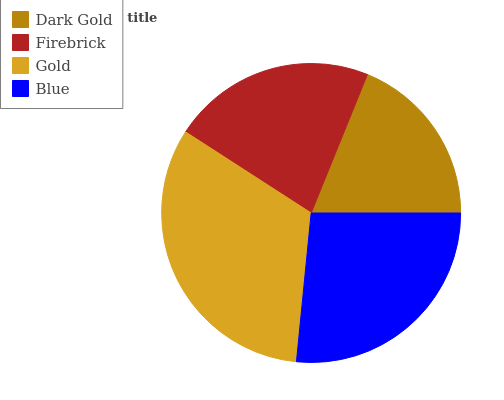Is Dark Gold the minimum?
Answer yes or no. Yes. Is Gold the maximum?
Answer yes or no. Yes. Is Firebrick the minimum?
Answer yes or no. No. Is Firebrick the maximum?
Answer yes or no. No. Is Firebrick greater than Dark Gold?
Answer yes or no. Yes. Is Dark Gold less than Firebrick?
Answer yes or no. Yes. Is Dark Gold greater than Firebrick?
Answer yes or no. No. Is Firebrick less than Dark Gold?
Answer yes or no. No. Is Blue the high median?
Answer yes or no. Yes. Is Firebrick the low median?
Answer yes or no. Yes. Is Firebrick the high median?
Answer yes or no. No. Is Blue the low median?
Answer yes or no. No. 